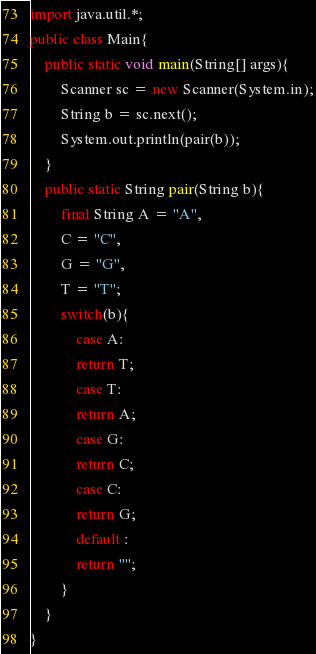<code> <loc_0><loc_0><loc_500><loc_500><_Java_>import java.util.*;
public class Main{
    public static void main(String[] args){
        Scanner sc = new Scanner(System.in);
        String b = sc.next();
        System.out.println(pair(b));
    }
    public static String pair(String b){
        final String A = "A",
        C = "C",
        G = "G",
        T = "T";
        switch(b){
            case A:
            return T;
            case T:
            return A;
            case G:
            return C;
            case C:
            return G;
            default :
            return "";
        }
    }
}</code> 